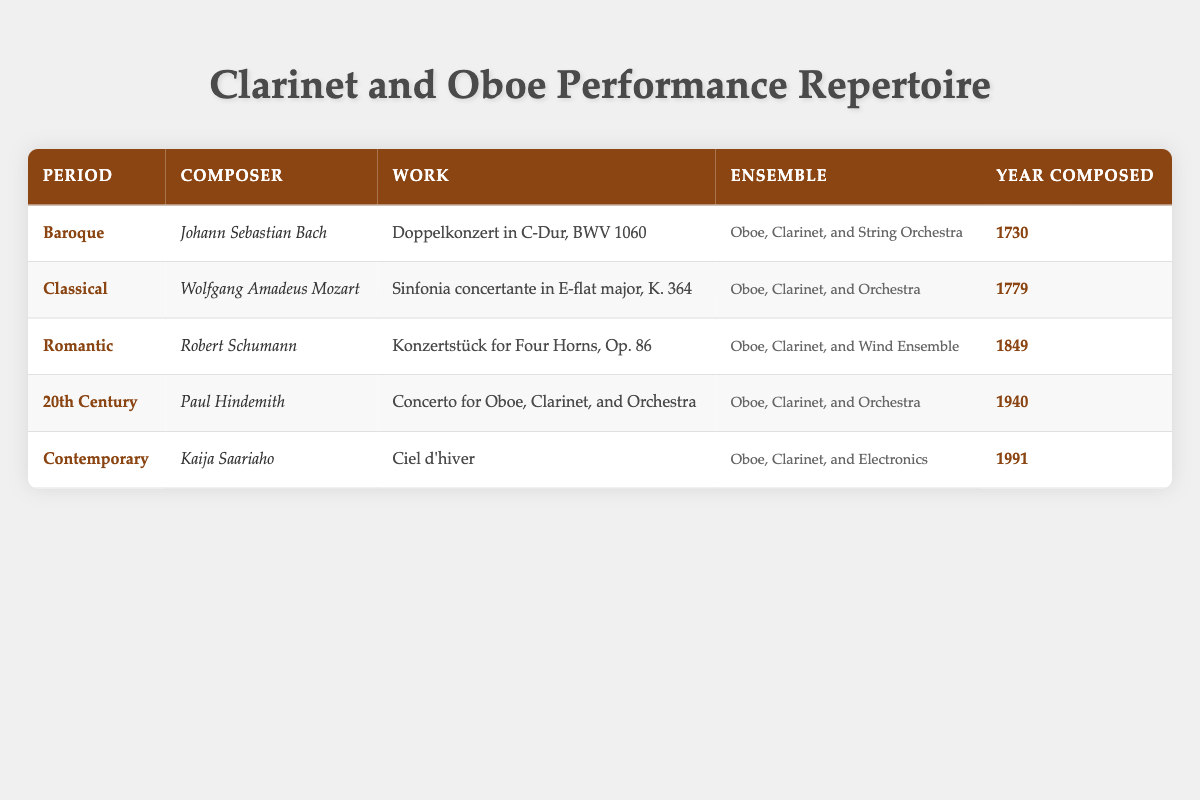What is the work composed by Wolfgang Amadeus Mozart for oboe and clarinet? The table shows that the work composed by Wolfgang Amadeus Mozart for both oboe and clarinet is "Sinfonia concertante in E-flat major, K. 364."
Answer: Sinfonia concertante in E-flat major, K. 364 Which composer wrote a piece for oboe and clarinet in the Romantic period? Referring to the table, Robert Schumann wrote "Konzertstück for Four Horns, Op. 86," which includes both oboe and clarinet in its ensemble during the Romantic period.
Answer: Robert Schumann Is there a composition by Paul Hindemith for oboe and clarinet in the 20th century? Yes, according to the table, Paul Hindemith composed "Concerto for Oboe, Clarinet, and Orchestra" in the 20th century.
Answer: Yes What ensemble is featured in the composition "Ciel d’hiver" by Kaija Saariaho? The table states that "Ciel d’hiver" by Kaija Saariaho is for "Oboe, Clarinet, and Electronics."
Answer: Oboe, Clarinet, and Electronics Which period has the earliest composed work in the table? The earliest composed work is "Doppelkonzert in C-Dur, BWV 1060" by Johann Sebastian Bach, which was composed in 1730, during the Baroque period. Comparing all years listed, 1730 is the earliest.
Answer: Baroque How many works in total are listed for the Contemporary period? The table shows that there is only one work listed for the Contemporary period, which is "Ciel d’hiver" by Kaija Saariaho. Thus, the total is 1.
Answer: 1 Which two periods have works for both an orchestra and the clarinet and oboe? By examining the table, the Classical period (Mozart's work) and the 20th Century (Hindemith's work) both have compositions for orchestra featuring oboe and clarinet.
Answer: Classical, 20th Century What is the average year of composition for the works listed in the Romantic and Contemporary periods? To find the average, we take the years for Romantic (1849) and Contemporary (1991). The sum is 1849 + 1991 = 3840, and we have 2 works, so the average is 3840/2 = 1920.
Answer: 1920 In which work does the oboe play with a wind ensemble? The table clearly indicates that "Konzertstück for Four Horns, Op. 86" by Robert Schumann features the oboe playing within a wind ensemble.
Answer: Konzertstück for Four Horns, Op. 86 